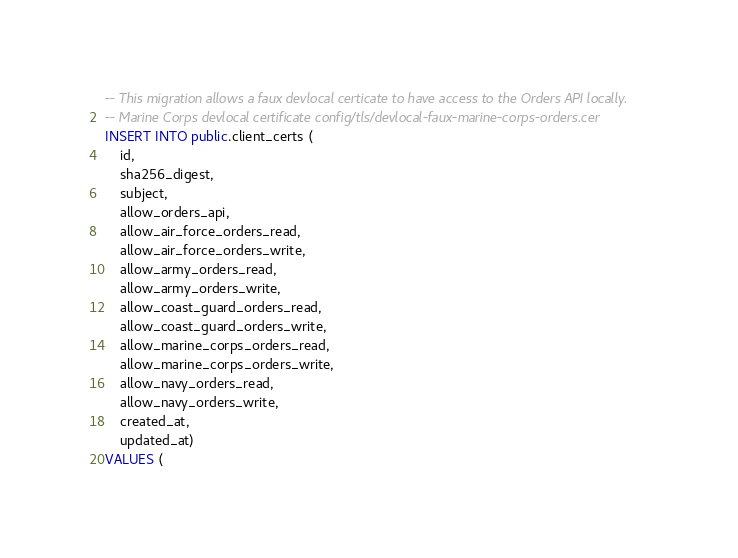Convert code to text. <code><loc_0><loc_0><loc_500><loc_500><_SQL_>-- This migration allows a faux devlocal certicate to have access to the Orders API locally.
-- Marine Corps devlocal certificate config/tls/devlocal-faux-marine-corps-orders.cer
INSERT INTO public.client_certs (
	id,
	sha256_digest,
	subject,
	allow_orders_api,
	allow_air_force_orders_read,
	allow_air_force_orders_write,
	allow_army_orders_read,
	allow_army_orders_write,
	allow_coast_guard_orders_read,
	allow_coast_guard_orders_write,
	allow_marine_corps_orders_read,
	allow_marine_corps_orders_write,
	allow_navy_orders_read,
	allow_navy_orders_write,
	created_at,
	updated_at)
VALUES (</code> 